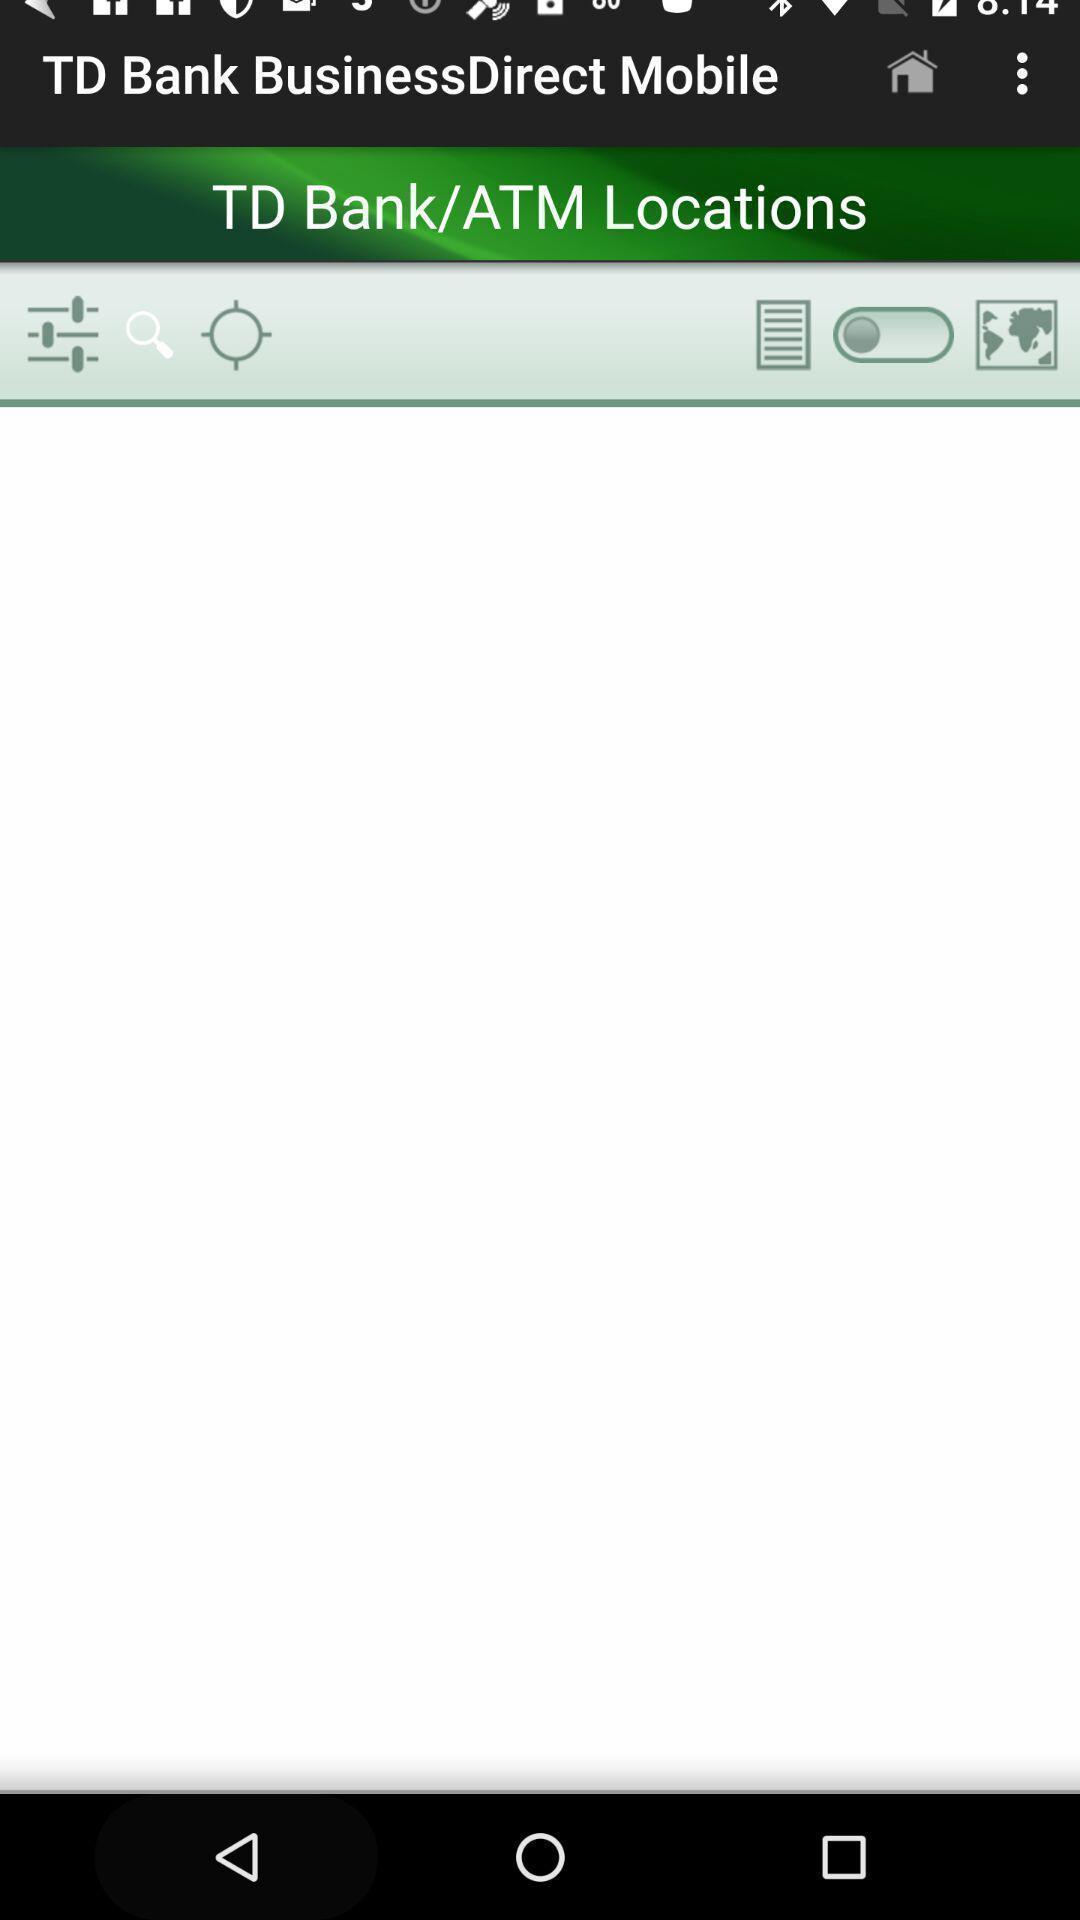Describe the content in this image. Screen showing the blank page of bank app. 